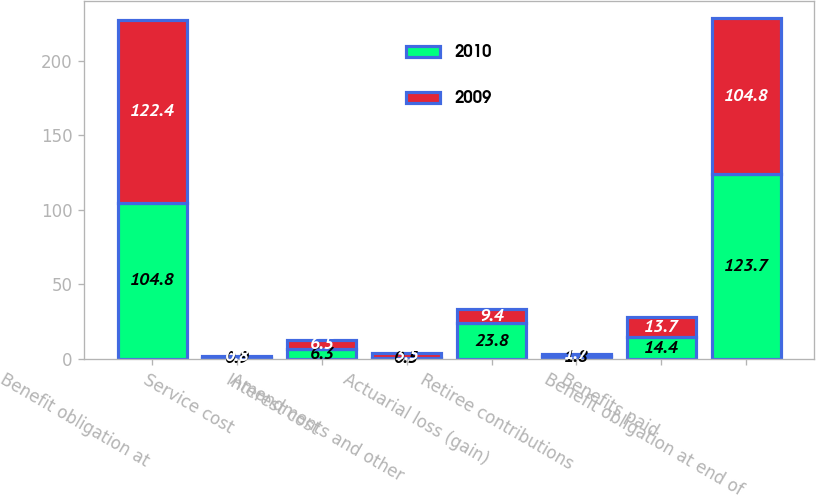Convert chart to OTSL. <chart><loc_0><loc_0><loc_500><loc_500><stacked_bar_chart><ecel><fcel>Benefit obligation at<fcel>Service cost<fcel>Interest cost<fcel>Amendments and other<fcel>Actuarial loss (gain)<fcel>Retiree contributions<fcel>Benefits paid<fcel>Benefit obligation at end of<nl><fcel>2010<fcel>104.8<fcel>0.9<fcel>6.3<fcel>0.5<fcel>23.8<fcel>1.8<fcel>14.4<fcel>123.7<nl><fcel>2009<fcel>122.4<fcel>0.8<fcel>6.5<fcel>3.5<fcel>9.4<fcel>1.7<fcel>13.7<fcel>104.8<nl></chart> 